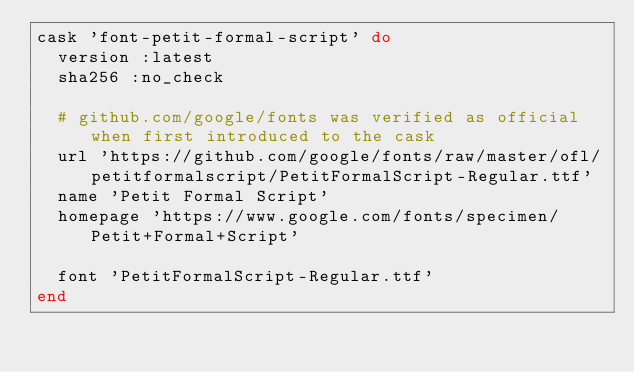Convert code to text. <code><loc_0><loc_0><loc_500><loc_500><_Ruby_>cask 'font-petit-formal-script' do
  version :latest
  sha256 :no_check

  # github.com/google/fonts was verified as official when first introduced to the cask
  url 'https://github.com/google/fonts/raw/master/ofl/petitformalscript/PetitFormalScript-Regular.ttf'
  name 'Petit Formal Script'
  homepage 'https://www.google.com/fonts/specimen/Petit+Formal+Script'

  font 'PetitFormalScript-Regular.ttf'
end
</code> 